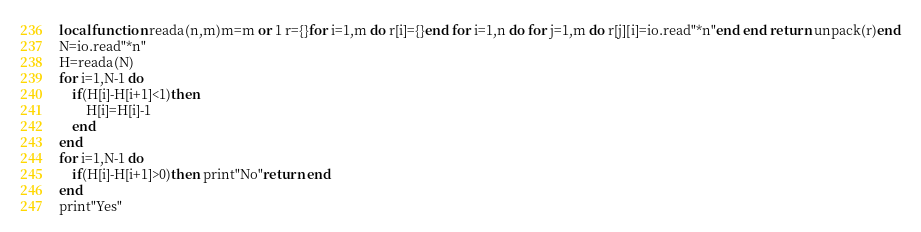<code> <loc_0><loc_0><loc_500><loc_500><_Lua_>local function reada(n,m)m=m or 1 r={}for i=1,m do r[i]={}end for i=1,n do for j=1,m do r[j][i]=io.read"*n"end end return unpack(r)end
N=io.read"*n"
H=reada(N)
for i=1,N-1 do
	if(H[i]-H[i+1]<1)then
		H[i]=H[i]-1
	end
end
for i=1,N-1 do
	if(H[i]-H[i+1]>0)then print"No"return end
end
print"Yes"</code> 